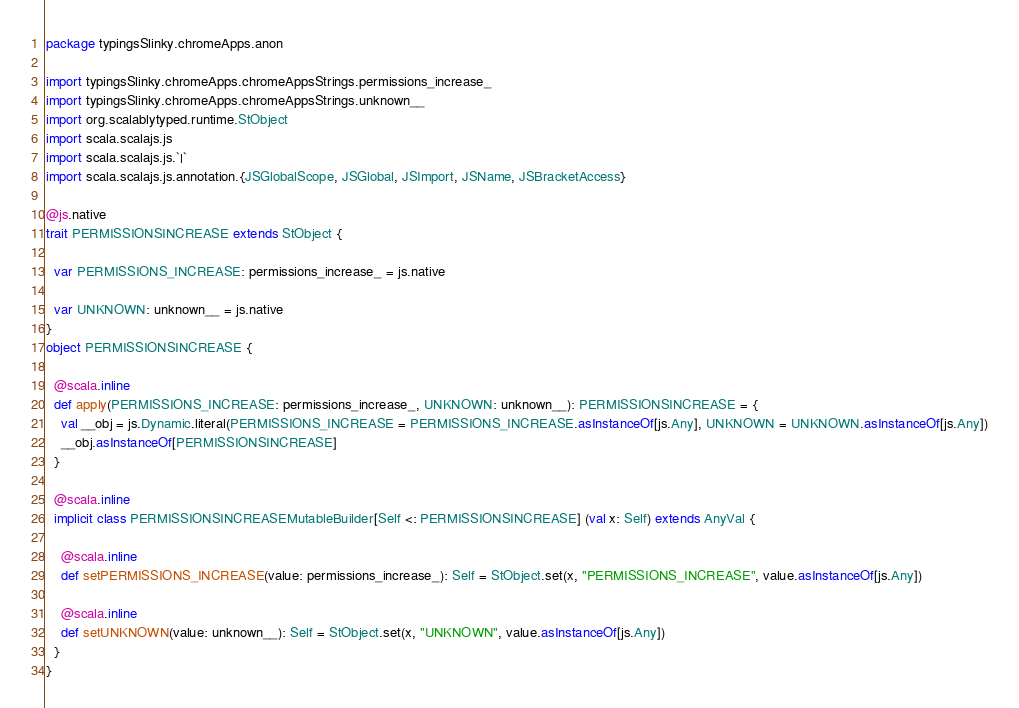<code> <loc_0><loc_0><loc_500><loc_500><_Scala_>package typingsSlinky.chromeApps.anon

import typingsSlinky.chromeApps.chromeAppsStrings.permissions_increase_
import typingsSlinky.chromeApps.chromeAppsStrings.unknown__
import org.scalablytyped.runtime.StObject
import scala.scalajs.js
import scala.scalajs.js.`|`
import scala.scalajs.js.annotation.{JSGlobalScope, JSGlobal, JSImport, JSName, JSBracketAccess}

@js.native
trait PERMISSIONSINCREASE extends StObject {
  
  var PERMISSIONS_INCREASE: permissions_increase_ = js.native
  
  var UNKNOWN: unknown__ = js.native
}
object PERMISSIONSINCREASE {
  
  @scala.inline
  def apply(PERMISSIONS_INCREASE: permissions_increase_, UNKNOWN: unknown__): PERMISSIONSINCREASE = {
    val __obj = js.Dynamic.literal(PERMISSIONS_INCREASE = PERMISSIONS_INCREASE.asInstanceOf[js.Any], UNKNOWN = UNKNOWN.asInstanceOf[js.Any])
    __obj.asInstanceOf[PERMISSIONSINCREASE]
  }
  
  @scala.inline
  implicit class PERMISSIONSINCREASEMutableBuilder[Self <: PERMISSIONSINCREASE] (val x: Self) extends AnyVal {
    
    @scala.inline
    def setPERMISSIONS_INCREASE(value: permissions_increase_): Self = StObject.set(x, "PERMISSIONS_INCREASE", value.asInstanceOf[js.Any])
    
    @scala.inline
    def setUNKNOWN(value: unknown__): Self = StObject.set(x, "UNKNOWN", value.asInstanceOf[js.Any])
  }
}
</code> 